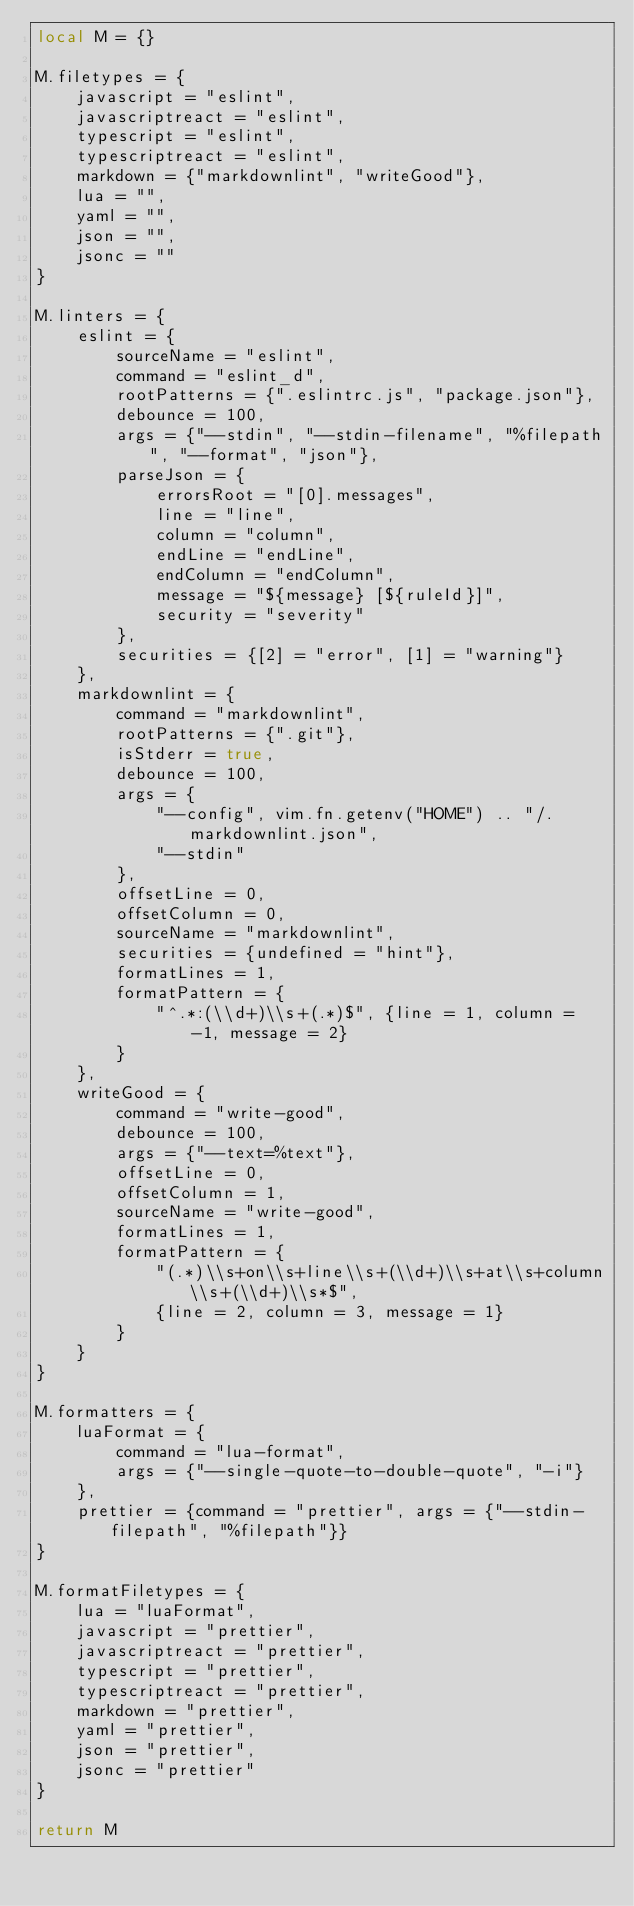Convert code to text. <code><loc_0><loc_0><loc_500><loc_500><_Lua_>local M = {}

M.filetypes = {
    javascript = "eslint",
    javascriptreact = "eslint",
    typescript = "eslint",
    typescriptreact = "eslint",
    markdown = {"markdownlint", "writeGood"},
    lua = "",
    yaml = "",
    json = "",
    jsonc = ""
}

M.linters = {
    eslint = {
        sourceName = "eslint",
        command = "eslint_d",
        rootPatterns = {".eslintrc.js", "package.json"},
        debounce = 100,
        args = {"--stdin", "--stdin-filename", "%filepath", "--format", "json"},
        parseJson = {
            errorsRoot = "[0].messages",
            line = "line",
            column = "column",
            endLine = "endLine",
            endColumn = "endColumn",
            message = "${message} [${ruleId}]",
            security = "severity"
        },
        securities = {[2] = "error", [1] = "warning"}
    },
    markdownlint = {
        command = "markdownlint",
        rootPatterns = {".git"},
        isStderr = true,
        debounce = 100,
        args = {
            "--config", vim.fn.getenv("HOME") .. "/.markdownlint.json",
            "--stdin"
        },
        offsetLine = 0,
        offsetColumn = 0,
        sourceName = "markdownlint",
        securities = {undefined = "hint"},
        formatLines = 1,
        formatPattern = {
            "^.*:(\\d+)\\s+(.*)$", {line = 1, column = -1, message = 2}
        }
    },
    writeGood = {
        command = "write-good",
        debounce = 100,
        args = {"--text=%text"},
        offsetLine = 0,
        offsetColumn = 1,
        sourceName = "write-good",
        formatLines = 1,
        formatPattern = {
            "(.*)\\s+on\\s+line\\s+(\\d+)\\s+at\\s+column\\s+(\\d+)\\s*$",
            {line = 2, column = 3, message = 1}
        }
    }
}

M.formatters = {
    luaFormat = {
        command = "lua-format",
        args = {"--single-quote-to-double-quote", "-i"}
    },
    prettier = {command = "prettier", args = {"--stdin-filepath", "%filepath"}}
}

M.formatFiletypes = {
    lua = "luaFormat",
    javascript = "prettier",
    javascriptreact = "prettier",
    typescript = "prettier",
    typescriptreact = "prettier",
    markdown = "prettier",
    yaml = "prettier",
    json = "prettier",
    jsonc = "prettier"
}

return M
</code> 